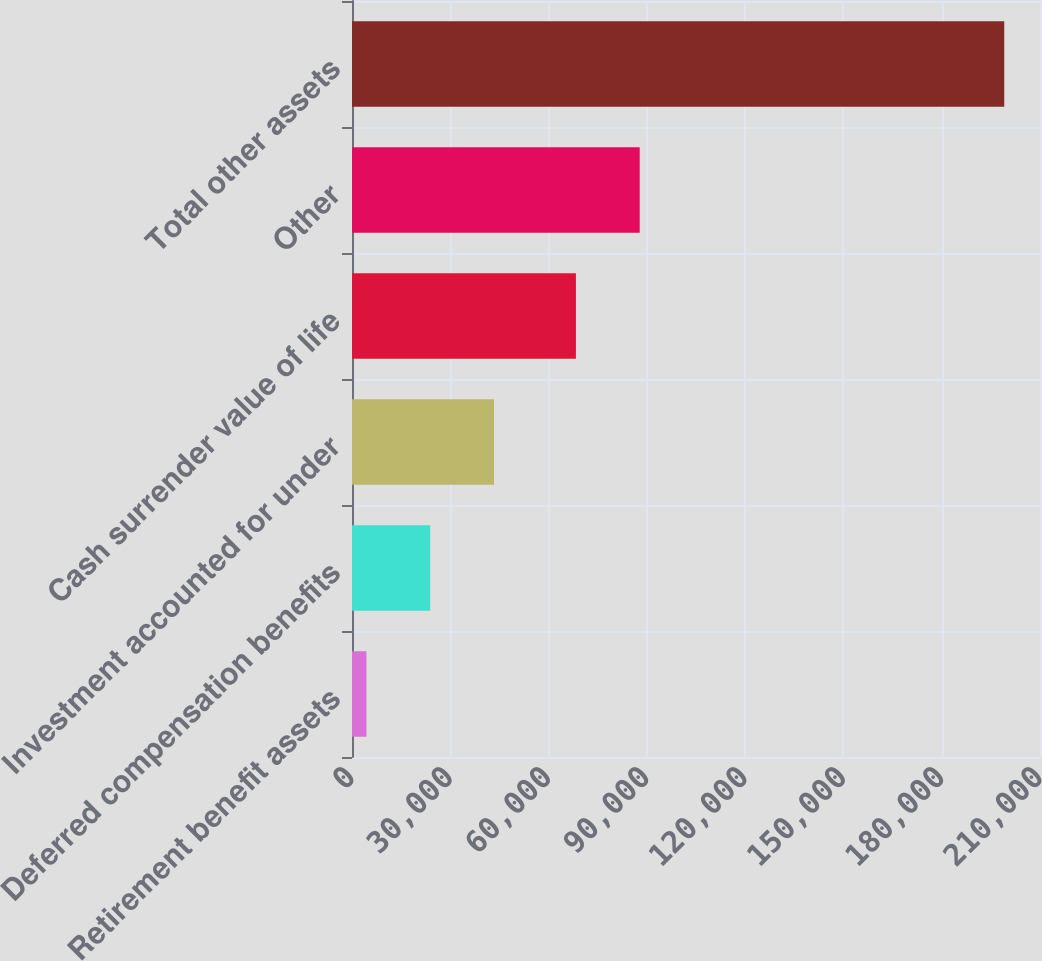Convert chart to OTSL. <chart><loc_0><loc_0><loc_500><loc_500><bar_chart><fcel>Retirement benefit assets<fcel>Deferred compensation benefits<fcel>Investment accounted for under<fcel>Cash surrender value of life<fcel>Other<fcel>Total other assets<nl><fcel>4405<fcel>23873.2<fcel>43341.4<fcel>68348<fcel>87816.2<fcel>199087<nl></chart> 